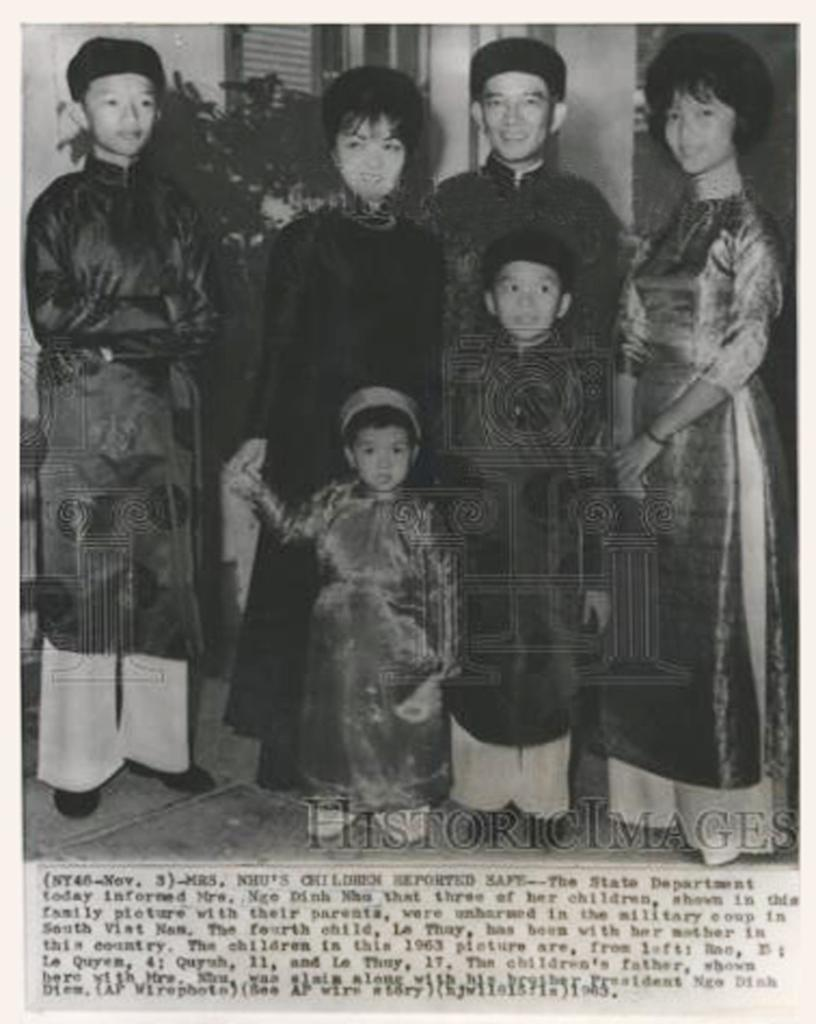What is the color scheme of the image? The image is black and white. What can be seen in the middle of the image? There is a group of persons standing in the middle of the image. Is there any text present in the image? Yes, there is some text written at the bottom of the image. What type of magic is being performed by the group of persons in the image? There is no indication of magic or any magical act being performed in the image. 